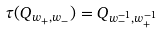Convert formula to latex. <formula><loc_0><loc_0><loc_500><loc_500>\tau ( Q _ { w _ { + } , w _ { - } } ) = Q _ { w _ { - } ^ { - 1 } , w _ { + } ^ { - 1 } }</formula> 